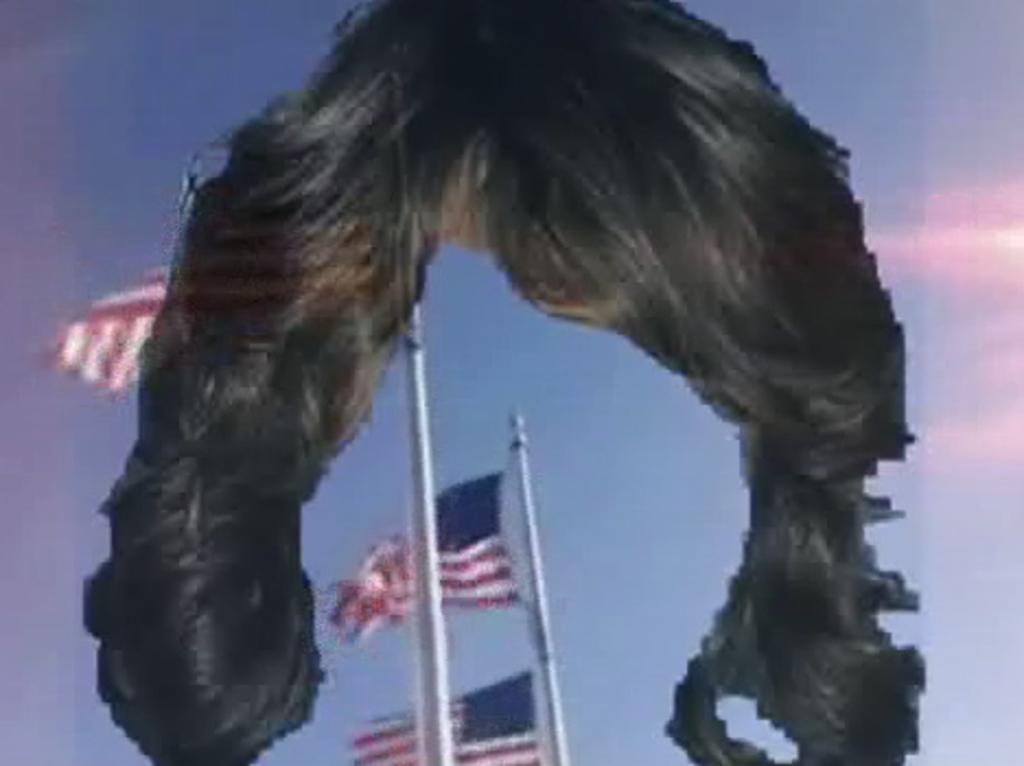What type of accessory is present in the image? There is a wig in the image. What other objects can be seen in the image? There are poles and flags in the image. What can be seen in the background of the image? There is a sky visible in the background of the image. What type of payment is being made in the image? There is no payment being made in the image; it features a wig, poles, and flags. What is the wig being used for in the image? The wig's purpose cannot be determined from the image alone, as it is a static object. 